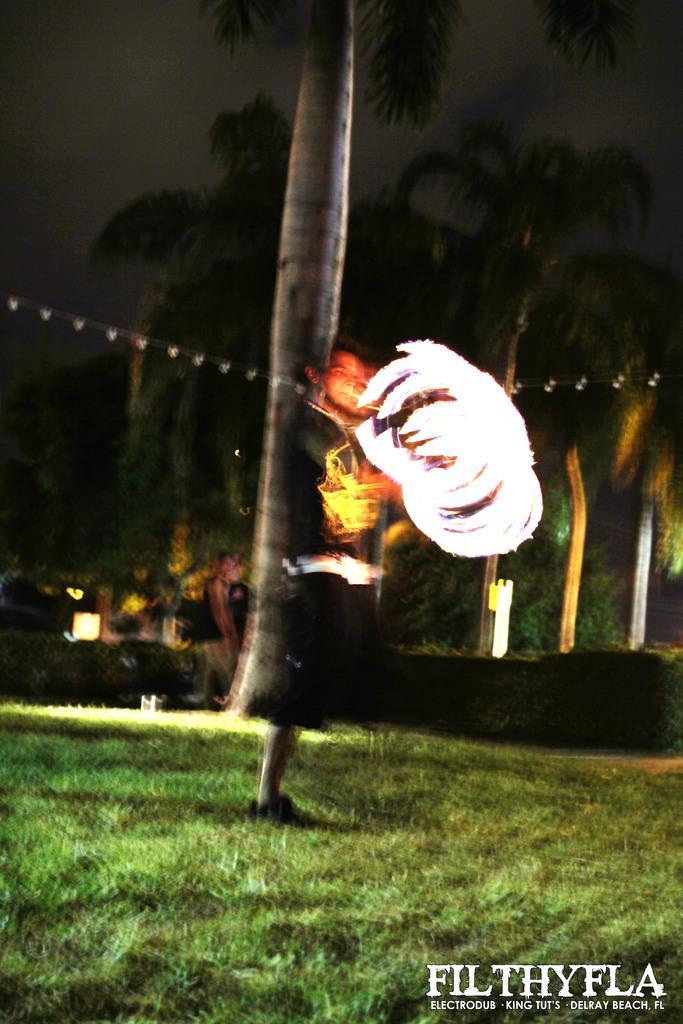Describe this image in one or two sentences. This is an image clicked in the dark. In this image, I can see many trees and lights. At the bottom, I can see the grass. In the bottom right-hand corner there is some text. The background is dark. 